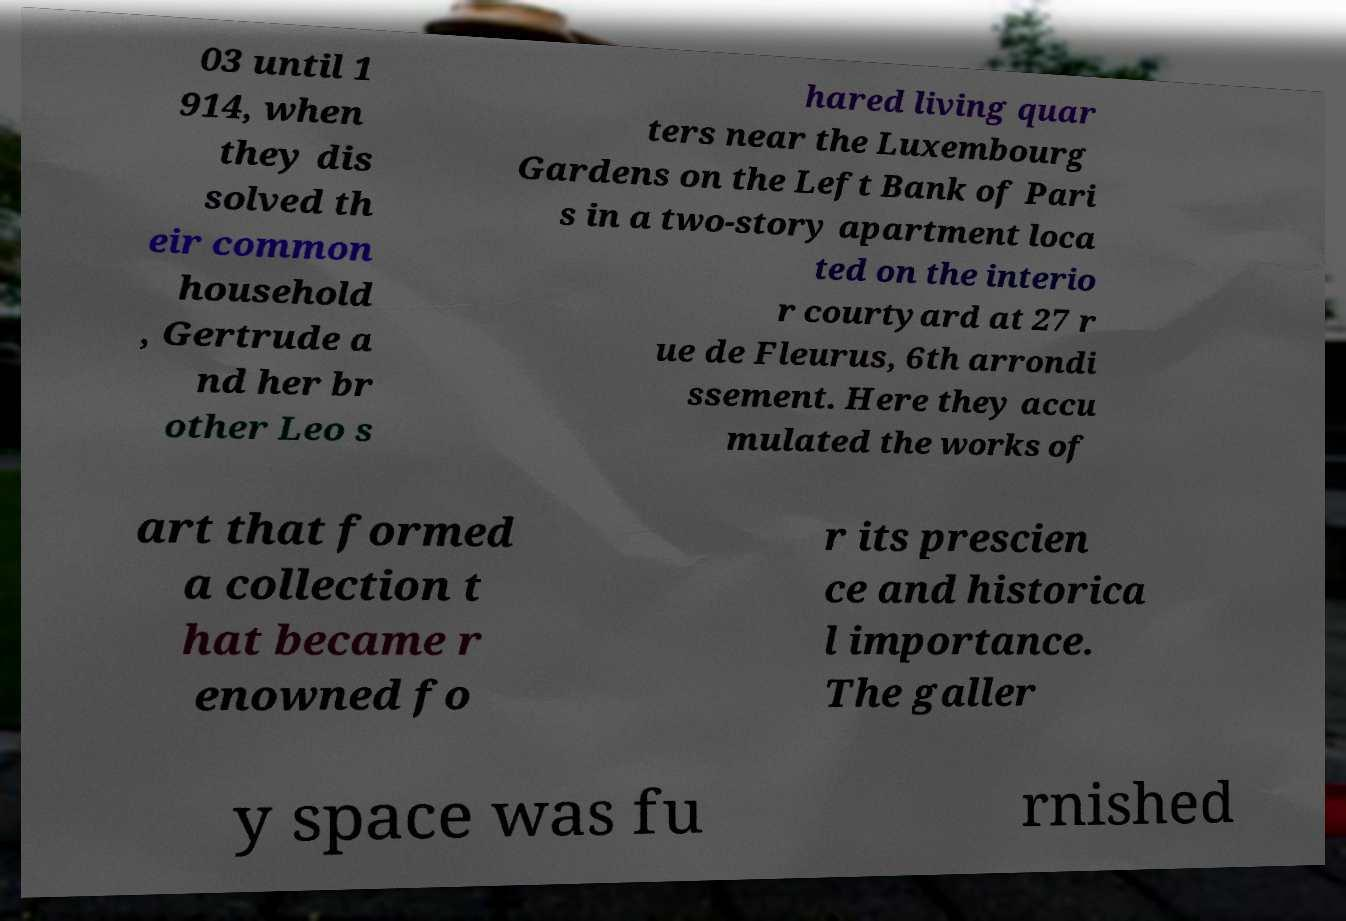Can you accurately transcribe the text from the provided image for me? 03 until 1 914, when they dis solved th eir common household , Gertrude a nd her br other Leo s hared living quar ters near the Luxembourg Gardens on the Left Bank of Pari s in a two-story apartment loca ted on the interio r courtyard at 27 r ue de Fleurus, 6th arrondi ssement. Here they accu mulated the works of art that formed a collection t hat became r enowned fo r its prescien ce and historica l importance. The galler y space was fu rnished 